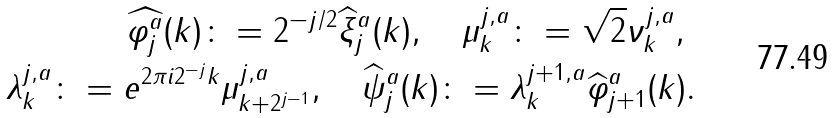Convert formula to latex. <formula><loc_0><loc_0><loc_500><loc_500>\widehat { \varphi _ { j } ^ { a } } ( k ) \colon = 2 ^ { - j / 2 } \widehat { \xi } _ { j } ^ { a } ( k ) , \quad \mu ^ { j , a } _ { k } \colon = \sqrt { 2 } \nu ^ { j , a } _ { k } , \ \\ \lambda ^ { j , a } _ { k } \colon = e ^ { 2 \pi i 2 ^ { - j } k } \mu ^ { j , a } _ { k + 2 ^ { j - 1 } } , \quad \widehat { \psi } _ { j } ^ { a } ( k ) \colon = \lambda ^ { j + 1 , a } _ { k } \widehat { \varphi } _ { j + 1 } ^ { a } ( k ) .</formula> 